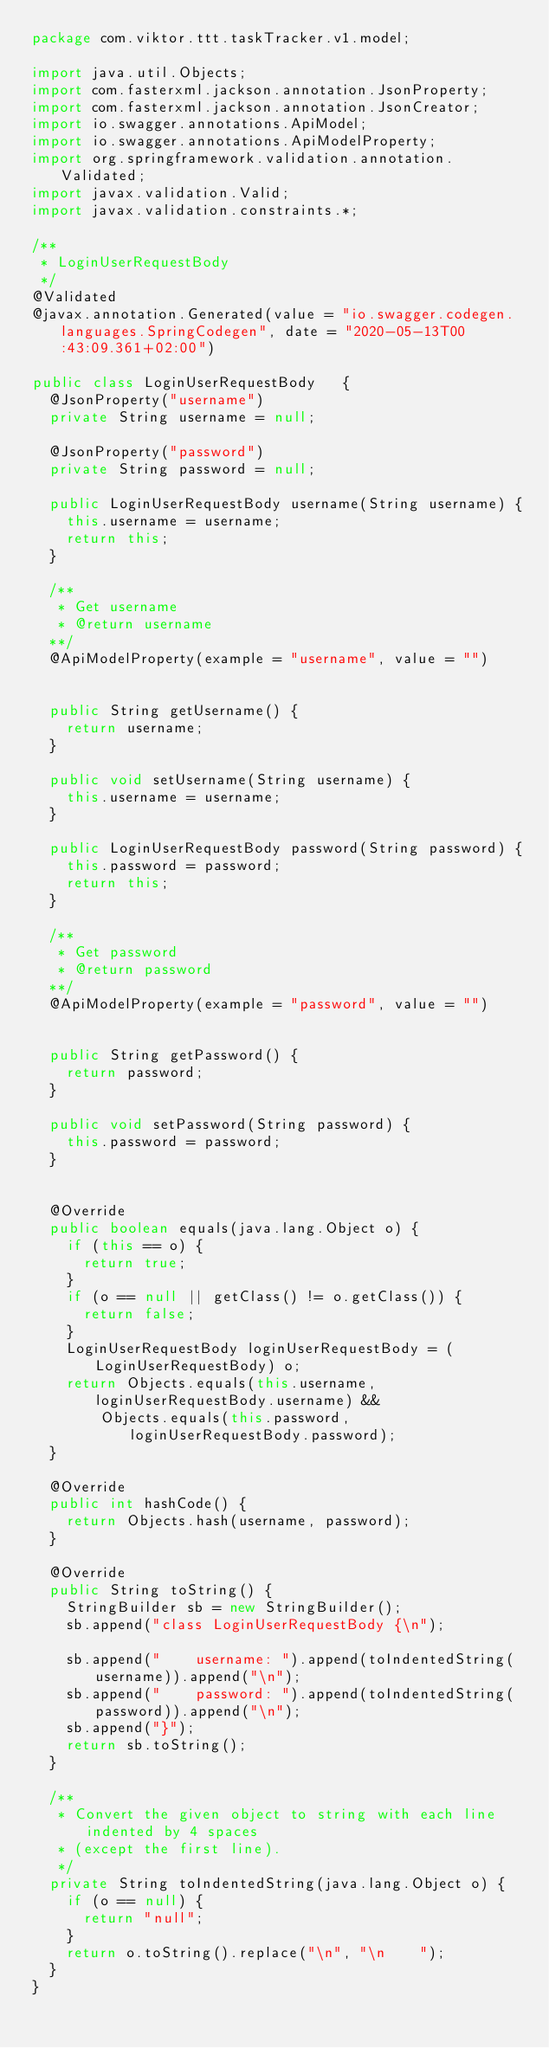<code> <loc_0><loc_0><loc_500><loc_500><_Java_>package com.viktor.ttt.taskTracker.v1.model;

import java.util.Objects;
import com.fasterxml.jackson.annotation.JsonProperty;
import com.fasterxml.jackson.annotation.JsonCreator;
import io.swagger.annotations.ApiModel;
import io.swagger.annotations.ApiModelProperty;
import org.springframework.validation.annotation.Validated;
import javax.validation.Valid;
import javax.validation.constraints.*;

/**
 * LoginUserRequestBody
 */
@Validated
@javax.annotation.Generated(value = "io.swagger.codegen.languages.SpringCodegen", date = "2020-05-13T00:43:09.361+02:00")

public class LoginUserRequestBody   {
  @JsonProperty("username")
  private String username = null;

  @JsonProperty("password")
  private String password = null;

  public LoginUserRequestBody username(String username) {
    this.username = username;
    return this;
  }

  /**
   * Get username
   * @return username
  **/
  @ApiModelProperty(example = "username", value = "")


  public String getUsername() {
    return username;
  }

  public void setUsername(String username) {
    this.username = username;
  }

  public LoginUserRequestBody password(String password) {
    this.password = password;
    return this;
  }

  /**
   * Get password
   * @return password
  **/
  @ApiModelProperty(example = "password", value = "")


  public String getPassword() {
    return password;
  }

  public void setPassword(String password) {
    this.password = password;
  }


  @Override
  public boolean equals(java.lang.Object o) {
    if (this == o) {
      return true;
    }
    if (o == null || getClass() != o.getClass()) {
      return false;
    }
    LoginUserRequestBody loginUserRequestBody = (LoginUserRequestBody) o;
    return Objects.equals(this.username, loginUserRequestBody.username) &&
        Objects.equals(this.password, loginUserRequestBody.password);
  }

  @Override
  public int hashCode() {
    return Objects.hash(username, password);
  }

  @Override
  public String toString() {
    StringBuilder sb = new StringBuilder();
    sb.append("class LoginUserRequestBody {\n");
    
    sb.append("    username: ").append(toIndentedString(username)).append("\n");
    sb.append("    password: ").append(toIndentedString(password)).append("\n");
    sb.append("}");
    return sb.toString();
  }

  /**
   * Convert the given object to string with each line indented by 4 spaces
   * (except the first line).
   */
  private String toIndentedString(java.lang.Object o) {
    if (o == null) {
      return "null";
    }
    return o.toString().replace("\n", "\n    ");
  }
}

</code> 